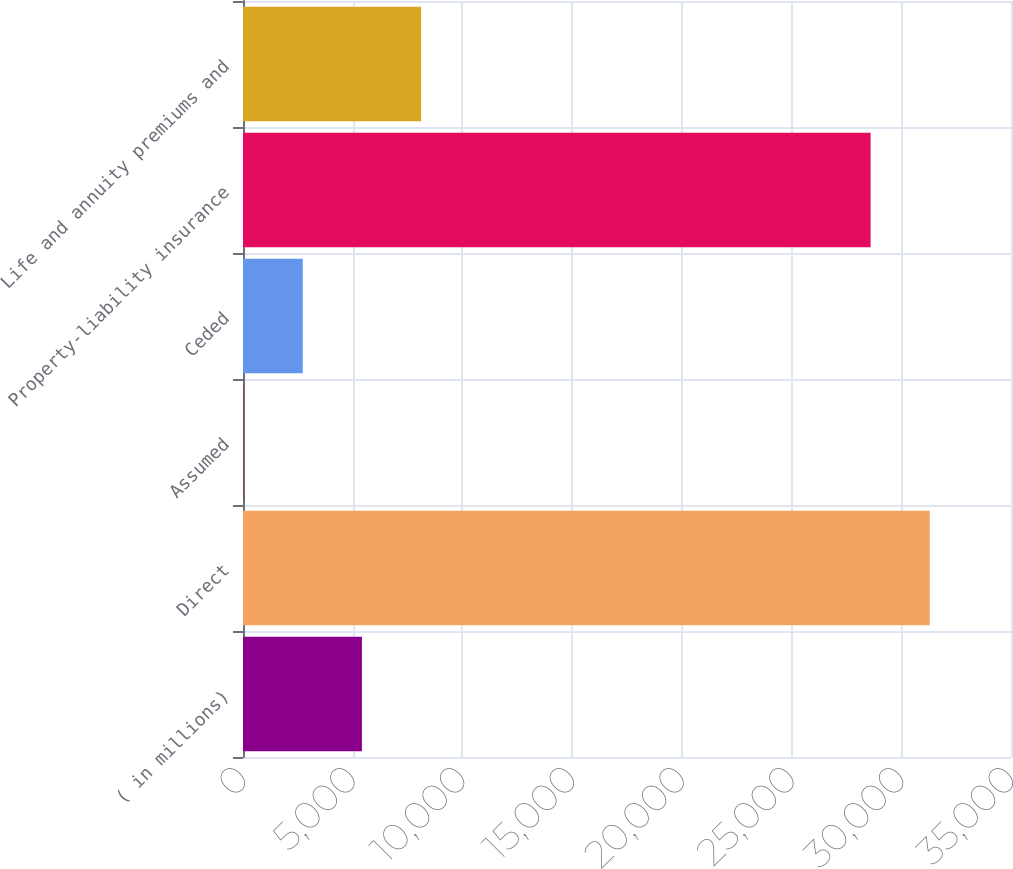Convert chart to OTSL. <chart><loc_0><loc_0><loc_500><loc_500><bar_chart><fcel>( in millions)<fcel>Direct<fcel>Assumed<fcel>Ceded<fcel>Property-liability insurance<fcel>Life and annuity premiums and<nl><fcel>5420<fcel>31298<fcel>29<fcel>2724.5<fcel>28602.5<fcel>8115.5<nl></chart> 